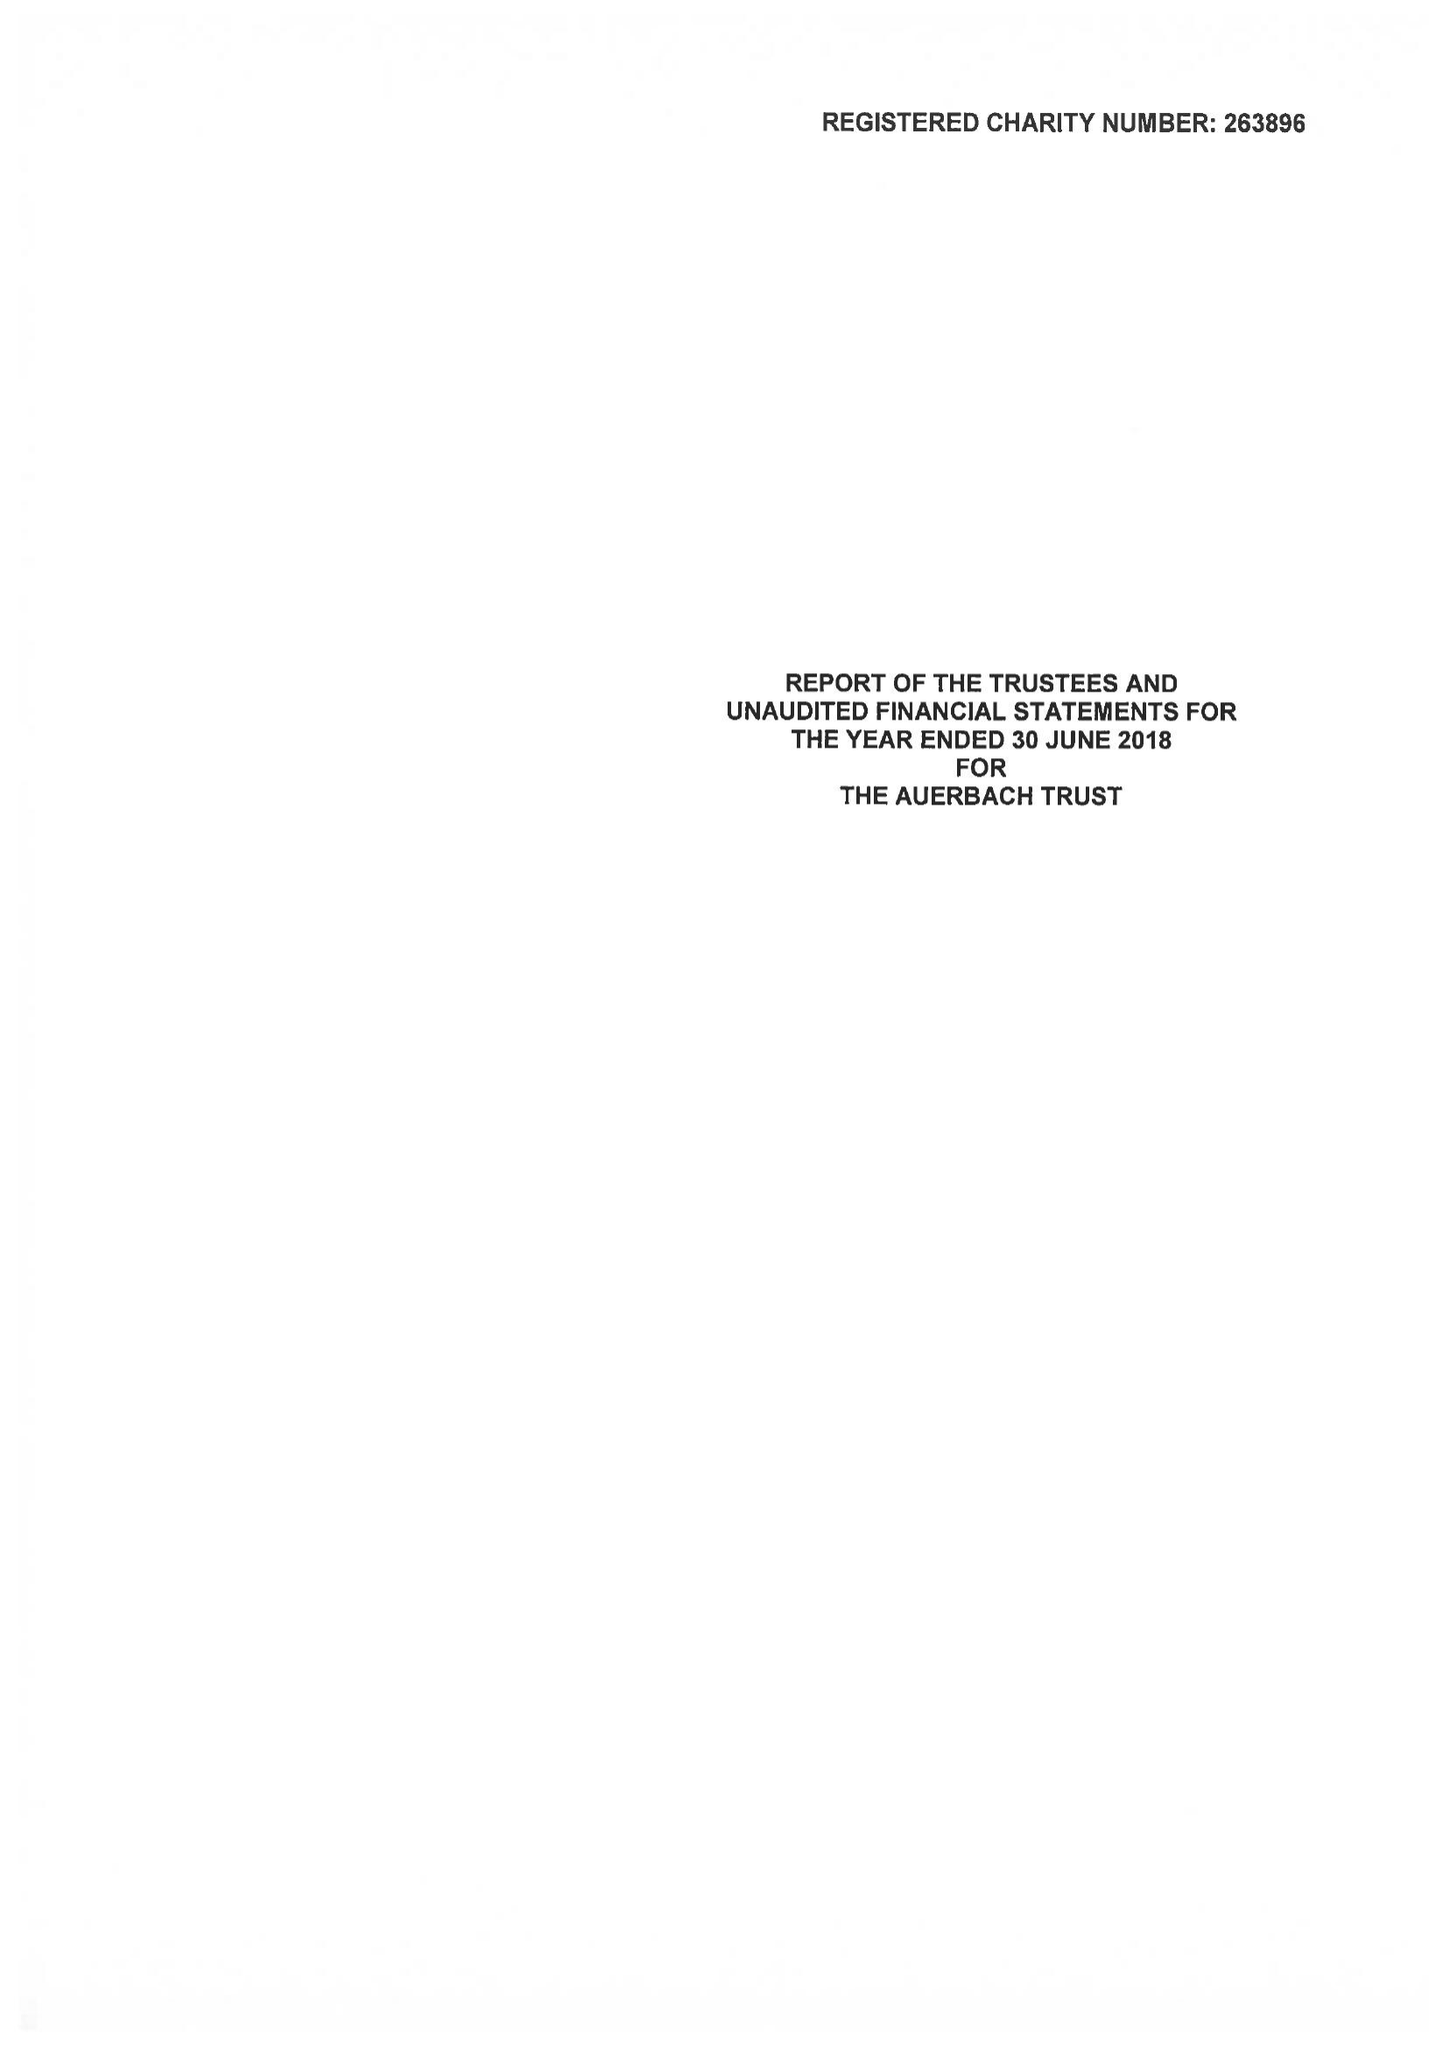What is the value for the spending_annually_in_british_pounds?
Answer the question using a single word or phrase. 25482.00 